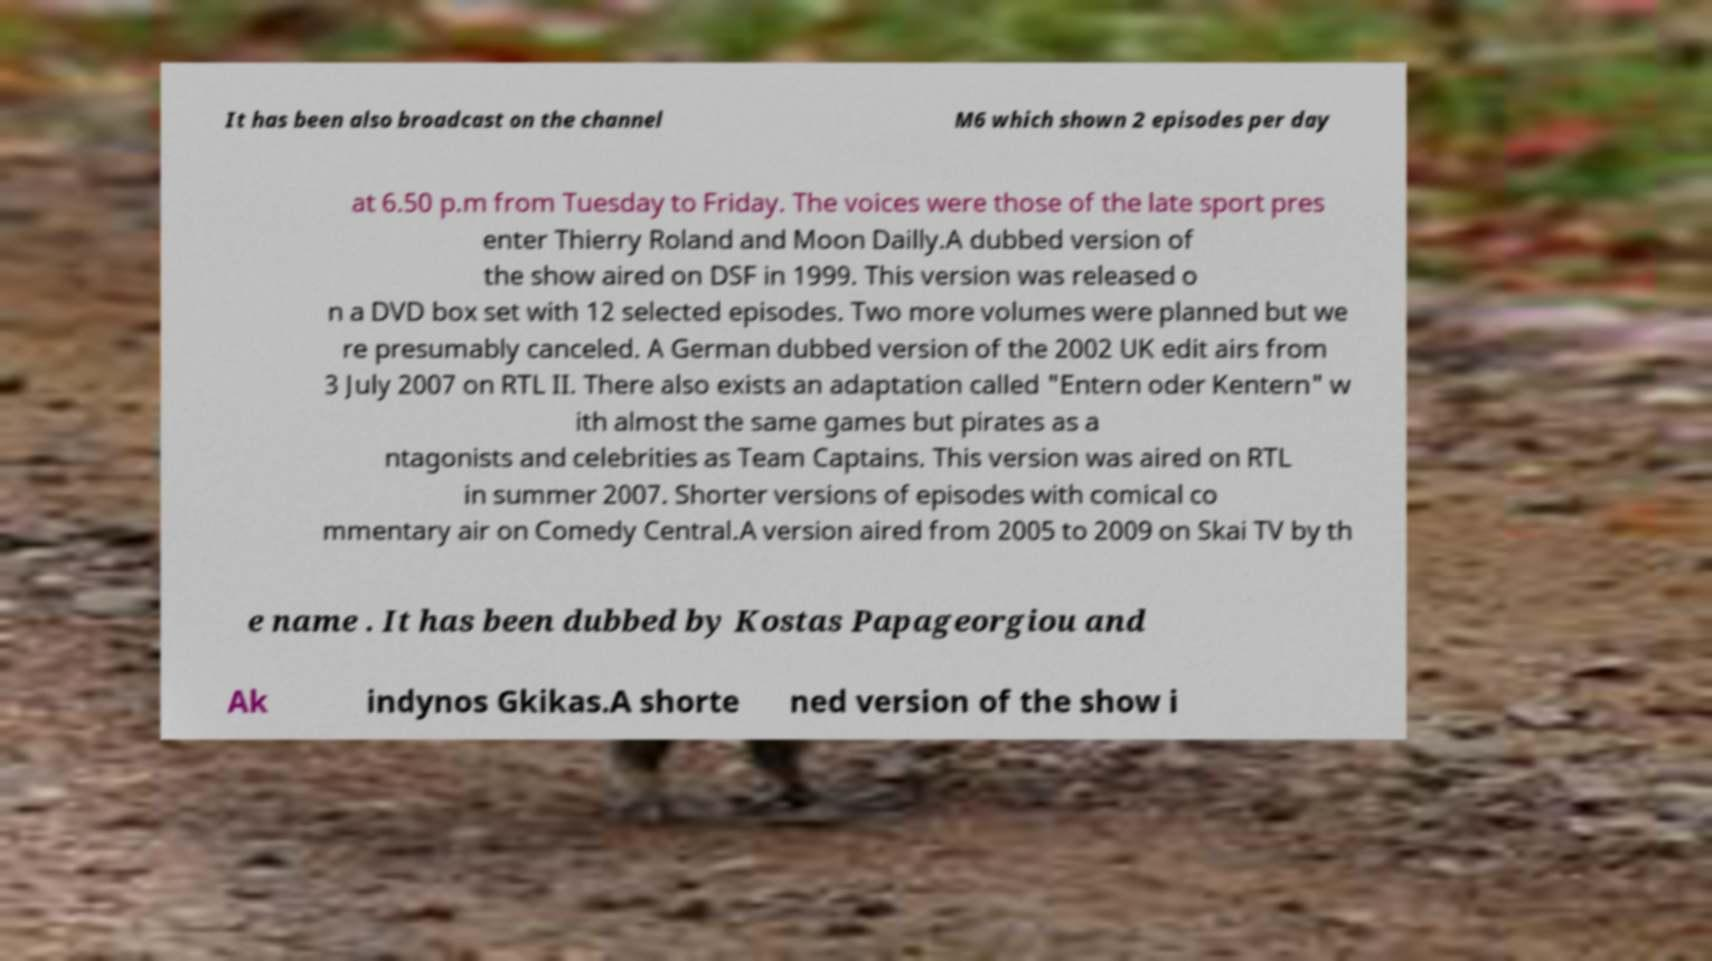Could you extract and type out the text from this image? It has been also broadcast on the channel M6 which shown 2 episodes per day at 6.50 p.m from Tuesday to Friday. The voices were those of the late sport pres enter Thierry Roland and Moon Dailly.A dubbed version of the show aired on DSF in 1999. This version was released o n a DVD box set with 12 selected episodes. Two more volumes were planned but we re presumably canceled. A German dubbed version of the 2002 UK edit airs from 3 July 2007 on RTL II. There also exists an adaptation called "Entern oder Kentern" w ith almost the same games but pirates as a ntagonists and celebrities as Team Captains. This version was aired on RTL in summer 2007. Shorter versions of episodes with comical co mmentary air on Comedy Central.A version aired from 2005 to 2009 on Skai TV by th e name . It has been dubbed by Kostas Papageorgiou and Ak indynos Gkikas.A shorte ned version of the show i 